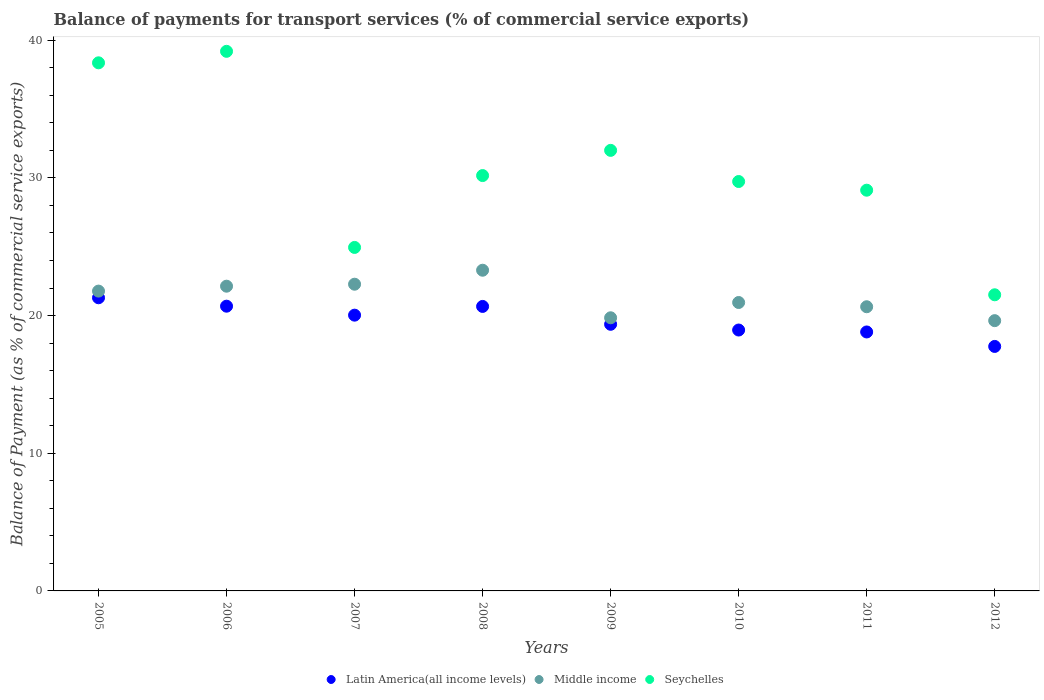Is the number of dotlines equal to the number of legend labels?
Give a very brief answer. Yes. What is the balance of payments for transport services in Seychelles in 2005?
Ensure brevity in your answer.  38.36. Across all years, what is the maximum balance of payments for transport services in Middle income?
Provide a short and direct response. 23.3. Across all years, what is the minimum balance of payments for transport services in Middle income?
Make the answer very short. 19.63. In which year was the balance of payments for transport services in Seychelles minimum?
Provide a short and direct response. 2012. What is the total balance of payments for transport services in Seychelles in the graph?
Ensure brevity in your answer.  245.04. What is the difference between the balance of payments for transport services in Seychelles in 2006 and that in 2010?
Give a very brief answer. 9.46. What is the difference between the balance of payments for transport services in Latin America(all income levels) in 2012 and the balance of payments for transport services in Middle income in 2007?
Provide a succinct answer. -4.52. What is the average balance of payments for transport services in Middle income per year?
Your response must be concise. 21.32. In the year 2011, what is the difference between the balance of payments for transport services in Middle income and balance of payments for transport services in Seychelles?
Your answer should be compact. -8.47. In how many years, is the balance of payments for transport services in Middle income greater than 36 %?
Offer a terse response. 0. What is the ratio of the balance of payments for transport services in Latin America(all income levels) in 2005 to that in 2011?
Your response must be concise. 1.13. What is the difference between the highest and the second highest balance of payments for transport services in Seychelles?
Your answer should be very brief. 0.83. What is the difference between the highest and the lowest balance of payments for transport services in Seychelles?
Offer a very short reply. 17.68. In how many years, is the balance of payments for transport services in Seychelles greater than the average balance of payments for transport services in Seychelles taken over all years?
Offer a terse response. 3. Does the balance of payments for transport services in Latin America(all income levels) monotonically increase over the years?
Offer a terse response. No. Is the balance of payments for transport services in Latin America(all income levels) strictly less than the balance of payments for transport services in Middle income over the years?
Your answer should be compact. Yes. How many dotlines are there?
Ensure brevity in your answer.  3. Are the values on the major ticks of Y-axis written in scientific E-notation?
Your answer should be very brief. No. Does the graph contain grids?
Provide a succinct answer. No. How are the legend labels stacked?
Give a very brief answer. Horizontal. What is the title of the graph?
Make the answer very short. Balance of payments for transport services (% of commercial service exports). What is the label or title of the X-axis?
Offer a terse response. Years. What is the label or title of the Y-axis?
Make the answer very short. Balance of Payment (as % of commercial service exports). What is the Balance of Payment (as % of commercial service exports) in Latin America(all income levels) in 2005?
Ensure brevity in your answer.  21.29. What is the Balance of Payment (as % of commercial service exports) of Middle income in 2005?
Your answer should be very brief. 21.78. What is the Balance of Payment (as % of commercial service exports) in Seychelles in 2005?
Offer a terse response. 38.36. What is the Balance of Payment (as % of commercial service exports) in Latin America(all income levels) in 2006?
Your answer should be compact. 20.68. What is the Balance of Payment (as % of commercial service exports) in Middle income in 2006?
Make the answer very short. 22.14. What is the Balance of Payment (as % of commercial service exports) of Seychelles in 2006?
Give a very brief answer. 39.2. What is the Balance of Payment (as % of commercial service exports) in Latin America(all income levels) in 2007?
Provide a short and direct response. 20.03. What is the Balance of Payment (as % of commercial service exports) of Middle income in 2007?
Your answer should be very brief. 22.28. What is the Balance of Payment (as % of commercial service exports) of Seychelles in 2007?
Provide a short and direct response. 24.95. What is the Balance of Payment (as % of commercial service exports) in Latin America(all income levels) in 2008?
Your answer should be compact. 20.67. What is the Balance of Payment (as % of commercial service exports) of Middle income in 2008?
Offer a terse response. 23.3. What is the Balance of Payment (as % of commercial service exports) in Seychelles in 2008?
Offer a very short reply. 30.17. What is the Balance of Payment (as % of commercial service exports) in Latin America(all income levels) in 2009?
Provide a short and direct response. 19.37. What is the Balance of Payment (as % of commercial service exports) in Middle income in 2009?
Your response must be concise. 19.84. What is the Balance of Payment (as % of commercial service exports) in Seychelles in 2009?
Offer a terse response. 32. What is the Balance of Payment (as % of commercial service exports) in Latin America(all income levels) in 2010?
Provide a succinct answer. 18.95. What is the Balance of Payment (as % of commercial service exports) of Middle income in 2010?
Your answer should be compact. 20.95. What is the Balance of Payment (as % of commercial service exports) of Seychelles in 2010?
Provide a succinct answer. 29.74. What is the Balance of Payment (as % of commercial service exports) in Latin America(all income levels) in 2011?
Keep it short and to the point. 18.81. What is the Balance of Payment (as % of commercial service exports) of Middle income in 2011?
Offer a terse response. 20.64. What is the Balance of Payment (as % of commercial service exports) of Seychelles in 2011?
Ensure brevity in your answer.  29.11. What is the Balance of Payment (as % of commercial service exports) of Latin America(all income levels) in 2012?
Make the answer very short. 17.76. What is the Balance of Payment (as % of commercial service exports) of Middle income in 2012?
Provide a short and direct response. 19.63. What is the Balance of Payment (as % of commercial service exports) of Seychelles in 2012?
Offer a terse response. 21.51. Across all years, what is the maximum Balance of Payment (as % of commercial service exports) of Latin America(all income levels)?
Provide a succinct answer. 21.29. Across all years, what is the maximum Balance of Payment (as % of commercial service exports) of Middle income?
Provide a short and direct response. 23.3. Across all years, what is the maximum Balance of Payment (as % of commercial service exports) of Seychelles?
Your answer should be compact. 39.2. Across all years, what is the minimum Balance of Payment (as % of commercial service exports) of Latin America(all income levels)?
Give a very brief answer. 17.76. Across all years, what is the minimum Balance of Payment (as % of commercial service exports) in Middle income?
Offer a terse response. 19.63. Across all years, what is the minimum Balance of Payment (as % of commercial service exports) in Seychelles?
Provide a short and direct response. 21.51. What is the total Balance of Payment (as % of commercial service exports) in Latin America(all income levels) in the graph?
Provide a succinct answer. 157.57. What is the total Balance of Payment (as % of commercial service exports) in Middle income in the graph?
Your response must be concise. 170.56. What is the total Balance of Payment (as % of commercial service exports) of Seychelles in the graph?
Your response must be concise. 245.04. What is the difference between the Balance of Payment (as % of commercial service exports) in Latin America(all income levels) in 2005 and that in 2006?
Offer a terse response. 0.61. What is the difference between the Balance of Payment (as % of commercial service exports) of Middle income in 2005 and that in 2006?
Provide a short and direct response. -0.36. What is the difference between the Balance of Payment (as % of commercial service exports) in Seychelles in 2005 and that in 2006?
Offer a terse response. -0.83. What is the difference between the Balance of Payment (as % of commercial service exports) of Latin America(all income levels) in 2005 and that in 2007?
Provide a succinct answer. 1.26. What is the difference between the Balance of Payment (as % of commercial service exports) in Middle income in 2005 and that in 2007?
Offer a very short reply. -0.5. What is the difference between the Balance of Payment (as % of commercial service exports) in Seychelles in 2005 and that in 2007?
Ensure brevity in your answer.  13.41. What is the difference between the Balance of Payment (as % of commercial service exports) of Latin America(all income levels) in 2005 and that in 2008?
Your answer should be compact. 0.63. What is the difference between the Balance of Payment (as % of commercial service exports) of Middle income in 2005 and that in 2008?
Offer a very short reply. -1.52. What is the difference between the Balance of Payment (as % of commercial service exports) of Seychelles in 2005 and that in 2008?
Keep it short and to the point. 8.19. What is the difference between the Balance of Payment (as % of commercial service exports) in Latin America(all income levels) in 2005 and that in 2009?
Provide a short and direct response. 1.93. What is the difference between the Balance of Payment (as % of commercial service exports) in Middle income in 2005 and that in 2009?
Your answer should be compact. 1.94. What is the difference between the Balance of Payment (as % of commercial service exports) of Seychelles in 2005 and that in 2009?
Keep it short and to the point. 6.36. What is the difference between the Balance of Payment (as % of commercial service exports) of Latin America(all income levels) in 2005 and that in 2010?
Your response must be concise. 2.34. What is the difference between the Balance of Payment (as % of commercial service exports) in Middle income in 2005 and that in 2010?
Your response must be concise. 0.83. What is the difference between the Balance of Payment (as % of commercial service exports) of Seychelles in 2005 and that in 2010?
Your response must be concise. 8.62. What is the difference between the Balance of Payment (as % of commercial service exports) of Latin America(all income levels) in 2005 and that in 2011?
Make the answer very short. 2.48. What is the difference between the Balance of Payment (as % of commercial service exports) in Middle income in 2005 and that in 2011?
Your response must be concise. 1.14. What is the difference between the Balance of Payment (as % of commercial service exports) of Seychelles in 2005 and that in 2011?
Make the answer very short. 9.25. What is the difference between the Balance of Payment (as % of commercial service exports) in Latin America(all income levels) in 2005 and that in 2012?
Ensure brevity in your answer.  3.54. What is the difference between the Balance of Payment (as % of commercial service exports) of Middle income in 2005 and that in 2012?
Your answer should be compact. 2.15. What is the difference between the Balance of Payment (as % of commercial service exports) in Seychelles in 2005 and that in 2012?
Make the answer very short. 16.85. What is the difference between the Balance of Payment (as % of commercial service exports) in Latin America(all income levels) in 2006 and that in 2007?
Offer a very short reply. 0.65. What is the difference between the Balance of Payment (as % of commercial service exports) of Middle income in 2006 and that in 2007?
Offer a terse response. -0.14. What is the difference between the Balance of Payment (as % of commercial service exports) in Seychelles in 2006 and that in 2007?
Keep it short and to the point. 14.25. What is the difference between the Balance of Payment (as % of commercial service exports) in Latin America(all income levels) in 2006 and that in 2008?
Make the answer very short. 0.02. What is the difference between the Balance of Payment (as % of commercial service exports) of Middle income in 2006 and that in 2008?
Your response must be concise. -1.16. What is the difference between the Balance of Payment (as % of commercial service exports) in Seychelles in 2006 and that in 2008?
Provide a short and direct response. 9.02. What is the difference between the Balance of Payment (as % of commercial service exports) of Latin America(all income levels) in 2006 and that in 2009?
Ensure brevity in your answer.  1.32. What is the difference between the Balance of Payment (as % of commercial service exports) of Middle income in 2006 and that in 2009?
Your answer should be compact. 2.29. What is the difference between the Balance of Payment (as % of commercial service exports) of Seychelles in 2006 and that in 2009?
Ensure brevity in your answer.  7.19. What is the difference between the Balance of Payment (as % of commercial service exports) in Latin America(all income levels) in 2006 and that in 2010?
Your answer should be very brief. 1.73. What is the difference between the Balance of Payment (as % of commercial service exports) of Middle income in 2006 and that in 2010?
Give a very brief answer. 1.19. What is the difference between the Balance of Payment (as % of commercial service exports) of Seychelles in 2006 and that in 2010?
Your answer should be very brief. 9.46. What is the difference between the Balance of Payment (as % of commercial service exports) of Latin America(all income levels) in 2006 and that in 2011?
Offer a terse response. 1.87. What is the difference between the Balance of Payment (as % of commercial service exports) of Middle income in 2006 and that in 2011?
Ensure brevity in your answer.  1.49. What is the difference between the Balance of Payment (as % of commercial service exports) of Seychelles in 2006 and that in 2011?
Provide a succinct answer. 10.09. What is the difference between the Balance of Payment (as % of commercial service exports) in Latin America(all income levels) in 2006 and that in 2012?
Your answer should be very brief. 2.92. What is the difference between the Balance of Payment (as % of commercial service exports) in Middle income in 2006 and that in 2012?
Offer a very short reply. 2.5. What is the difference between the Balance of Payment (as % of commercial service exports) of Seychelles in 2006 and that in 2012?
Make the answer very short. 17.68. What is the difference between the Balance of Payment (as % of commercial service exports) in Latin America(all income levels) in 2007 and that in 2008?
Keep it short and to the point. -0.63. What is the difference between the Balance of Payment (as % of commercial service exports) in Middle income in 2007 and that in 2008?
Give a very brief answer. -1.02. What is the difference between the Balance of Payment (as % of commercial service exports) in Seychelles in 2007 and that in 2008?
Provide a succinct answer. -5.22. What is the difference between the Balance of Payment (as % of commercial service exports) in Latin America(all income levels) in 2007 and that in 2009?
Provide a succinct answer. 0.66. What is the difference between the Balance of Payment (as % of commercial service exports) of Middle income in 2007 and that in 2009?
Your response must be concise. 2.44. What is the difference between the Balance of Payment (as % of commercial service exports) in Seychelles in 2007 and that in 2009?
Make the answer very short. -7.05. What is the difference between the Balance of Payment (as % of commercial service exports) of Latin America(all income levels) in 2007 and that in 2010?
Ensure brevity in your answer.  1.08. What is the difference between the Balance of Payment (as % of commercial service exports) of Middle income in 2007 and that in 2010?
Offer a terse response. 1.33. What is the difference between the Balance of Payment (as % of commercial service exports) of Seychelles in 2007 and that in 2010?
Offer a very short reply. -4.79. What is the difference between the Balance of Payment (as % of commercial service exports) in Latin America(all income levels) in 2007 and that in 2011?
Make the answer very short. 1.22. What is the difference between the Balance of Payment (as % of commercial service exports) in Middle income in 2007 and that in 2011?
Offer a very short reply. 1.64. What is the difference between the Balance of Payment (as % of commercial service exports) of Seychelles in 2007 and that in 2011?
Provide a succinct answer. -4.16. What is the difference between the Balance of Payment (as % of commercial service exports) of Latin America(all income levels) in 2007 and that in 2012?
Offer a very short reply. 2.27. What is the difference between the Balance of Payment (as % of commercial service exports) in Middle income in 2007 and that in 2012?
Provide a short and direct response. 2.65. What is the difference between the Balance of Payment (as % of commercial service exports) of Seychelles in 2007 and that in 2012?
Keep it short and to the point. 3.44. What is the difference between the Balance of Payment (as % of commercial service exports) in Latin America(all income levels) in 2008 and that in 2009?
Provide a short and direct response. 1.3. What is the difference between the Balance of Payment (as % of commercial service exports) of Middle income in 2008 and that in 2009?
Provide a short and direct response. 3.45. What is the difference between the Balance of Payment (as % of commercial service exports) in Seychelles in 2008 and that in 2009?
Keep it short and to the point. -1.83. What is the difference between the Balance of Payment (as % of commercial service exports) of Latin America(all income levels) in 2008 and that in 2010?
Ensure brevity in your answer.  1.71. What is the difference between the Balance of Payment (as % of commercial service exports) in Middle income in 2008 and that in 2010?
Keep it short and to the point. 2.34. What is the difference between the Balance of Payment (as % of commercial service exports) in Seychelles in 2008 and that in 2010?
Give a very brief answer. 0.43. What is the difference between the Balance of Payment (as % of commercial service exports) in Latin America(all income levels) in 2008 and that in 2011?
Give a very brief answer. 1.85. What is the difference between the Balance of Payment (as % of commercial service exports) in Middle income in 2008 and that in 2011?
Keep it short and to the point. 2.65. What is the difference between the Balance of Payment (as % of commercial service exports) of Seychelles in 2008 and that in 2011?
Provide a succinct answer. 1.06. What is the difference between the Balance of Payment (as % of commercial service exports) in Latin America(all income levels) in 2008 and that in 2012?
Provide a succinct answer. 2.91. What is the difference between the Balance of Payment (as % of commercial service exports) in Middle income in 2008 and that in 2012?
Make the answer very short. 3.66. What is the difference between the Balance of Payment (as % of commercial service exports) in Seychelles in 2008 and that in 2012?
Ensure brevity in your answer.  8.66. What is the difference between the Balance of Payment (as % of commercial service exports) of Latin America(all income levels) in 2009 and that in 2010?
Your response must be concise. 0.42. What is the difference between the Balance of Payment (as % of commercial service exports) in Middle income in 2009 and that in 2010?
Ensure brevity in your answer.  -1.11. What is the difference between the Balance of Payment (as % of commercial service exports) of Seychelles in 2009 and that in 2010?
Provide a succinct answer. 2.26. What is the difference between the Balance of Payment (as % of commercial service exports) in Latin America(all income levels) in 2009 and that in 2011?
Keep it short and to the point. 0.56. What is the difference between the Balance of Payment (as % of commercial service exports) in Middle income in 2009 and that in 2011?
Your answer should be very brief. -0.8. What is the difference between the Balance of Payment (as % of commercial service exports) in Seychelles in 2009 and that in 2011?
Keep it short and to the point. 2.89. What is the difference between the Balance of Payment (as % of commercial service exports) in Latin America(all income levels) in 2009 and that in 2012?
Make the answer very short. 1.61. What is the difference between the Balance of Payment (as % of commercial service exports) of Middle income in 2009 and that in 2012?
Keep it short and to the point. 0.21. What is the difference between the Balance of Payment (as % of commercial service exports) in Seychelles in 2009 and that in 2012?
Ensure brevity in your answer.  10.49. What is the difference between the Balance of Payment (as % of commercial service exports) in Latin America(all income levels) in 2010 and that in 2011?
Provide a short and direct response. 0.14. What is the difference between the Balance of Payment (as % of commercial service exports) in Middle income in 2010 and that in 2011?
Your answer should be compact. 0.31. What is the difference between the Balance of Payment (as % of commercial service exports) of Seychelles in 2010 and that in 2011?
Keep it short and to the point. 0.63. What is the difference between the Balance of Payment (as % of commercial service exports) of Latin America(all income levels) in 2010 and that in 2012?
Offer a very short reply. 1.19. What is the difference between the Balance of Payment (as % of commercial service exports) of Middle income in 2010 and that in 2012?
Provide a short and direct response. 1.32. What is the difference between the Balance of Payment (as % of commercial service exports) of Seychelles in 2010 and that in 2012?
Your response must be concise. 8.23. What is the difference between the Balance of Payment (as % of commercial service exports) in Latin America(all income levels) in 2011 and that in 2012?
Offer a very short reply. 1.05. What is the difference between the Balance of Payment (as % of commercial service exports) of Middle income in 2011 and that in 2012?
Your response must be concise. 1.01. What is the difference between the Balance of Payment (as % of commercial service exports) in Seychelles in 2011 and that in 2012?
Your answer should be very brief. 7.6. What is the difference between the Balance of Payment (as % of commercial service exports) in Latin America(all income levels) in 2005 and the Balance of Payment (as % of commercial service exports) in Middle income in 2006?
Provide a succinct answer. -0.84. What is the difference between the Balance of Payment (as % of commercial service exports) of Latin America(all income levels) in 2005 and the Balance of Payment (as % of commercial service exports) of Seychelles in 2006?
Ensure brevity in your answer.  -17.9. What is the difference between the Balance of Payment (as % of commercial service exports) in Middle income in 2005 and the Balance of Payment (as % of commercial service exports) in Seychelles in 2006?
Your answer should be very brief. -17.42. What is the difference between the Balance of Payment (as % of commercial service exports) in Latin America(all income levels) in 2005 and the Balance of Payment (as % of commercial service exports) in Middle income in 2007?
Offer a terse response. -0.98. What is the difference between the Balance of Payment (as % of commercial service exports) in Latin America(all income levels) in 2005 and the Balance of Payment (as % of commercial service exports) in Seychelles in 2007?
Provide a succinct answer. -3.66. What is the difference between the Balance of Payment (as % of commercial service exports) in Middle income in 2005 and the Balance of Payment (as % of commercial service exports) in Seychelles in 2007?
Offer a very short reply. -3.17. What is the difference between the Balance of Payment (as % of commercial service exports) of Latin America(all income levels) in 2005 and the Balance of Payment (as % of commercial service exports) of Middle income in 2008?
Make the answer very short. -2. What is the difference between the Balance of Payment (as % of commercial service exports) in Latin America(all income levels) in 2005 and the Balance of Payment (as % of commercial service exports) in Seychelles in 2008?
Offer a terse response. -8.88. What is the difference between the Balance of Payment (as % of commercial service exports) of Middle income in 2005 and the Balance of Payment (as % of commercial service exports) of Seychelles in 2008?
Make the answer very short. -8.39. What is the difference between the Balance of Payment (as % of commercial service exports) in Latin America(all income levels) in 2005 and the Balance of Payment (as % of commercial service exports) in Middle income in 2009?
Your answer should be compact. 1.45. What is the difference between the Balance of Payment (as % of commercial service exports) in Latin America(all income levels) in 2005 and the Balance of Payment (as % of commercial service exports) in Seychelles in 2009?
Your response must be concise. -10.71. What is the difference between the Balance of Payment (as % of commercial service exports) in Middle income in 2005 and the Balance of Payment (as % of commercial service exports) in Seychelles in 2009?
Your answer should be very brief. -10.22. What is the difference between the Balance of Payment (as % of commercial service exports) in Latin America(all income levels) in 2005 and the Balance of Payment (as % of commercial service exports) in Middle income in 2010?
Keep it short and to the point. 0.34. What is the difference between the Balance of Payment (as % of commercial service exports) of Latin America(all income levels) in 2005 and the Balance of Payment (as % of commercial service exports) of Seychelles in 2010?
Keep it short and to the point. -8.44. What is the difference between the Balance of Payment (as % of commercial service exports) of Middle income in 2005 and the Balance of Payment (as % of commercial service exports) of Seychelles in 2010?
Your answer should be very brief. -7.96. What is the difference between the Balance of Payment (as % of commercial service exports) of Latin America(all income levels) in 2005 and the Balance of Payment (as % of commercial service exports) of Middle income in 2011?
Give a very brief answer. 0.65. What is the difference between the Balance of Payment (as % of commercial service exports) of Latin America(all income levels) in 2005 and the Balance of Payment (as % of commercial service exports) of Seychelles in 2011?
Provide a short and direct response. -7.81. What is the difference between the Balance of Payment (as % of commercial service exports) of Middle income in 2005 and the Balance of Payment (as % of commercial service exports) of Seychelles in 2011?
Your answer should be very brief. -7.33. What is the difference between the Balance of Payment (as % of commercial service exports) of Latin America(all income levels) in 2005 and the Balance of Payment (as % of commercial service exports) of Middle income in 2012?
Your answer should be compact. 1.66. What is the difference between the Balance of Payment (as % of commercial service exports) of Latin America(all income levels) in 2005 and the Balance of Payment (as % of commercial service exports) of Seychelles in 2012?
Your answer should be very brief. -0.22. What is the difference between the Balance of Payment (as % of commercial service exports) of Middle income in 2005 and the Balance of Payment (as % of commercial service exports) of Seychelles in 2012?
Make the answer very short. 0.27. What is the difference between the Balance of Payment (as % of commercial service exports) in Latin America(all income levels) in 2006 and the Balance of Payment (as % of commercial service exports) in Middle income in 2007?
Keep it short and to the point. -1.6. What is the difference between the Balance of Payment (as % of commercial service exports) in Latin America(all income levels) in 2006 and the Balance of Payment (as % of commercial service exports) in Seychelles in 2007?
Your answer should be compact. -4.27. What is the difference between the Balance of Payment (as % of commercial service exports) in Middle income in 2006 and the Balance of Payment (as % of commercial service exports) in Seychelles in 2007?
Give a very brief answer. -2.82. What is the difference between the Balance of Payment (as % of commercial service exports) in Latin America(all income levels) in 2006 and the Balance of Payment (as % of commercial service exports) in Middle income in 2008?
Ensure brevity in your answer.  -2.61. What is the difference between the Balance of Payment (as % of commercial service exports) in Latin America(all income levels) in 2006 and the Balance of Payment (as % of commercial service exports) in Seychelles in 2008?
Ensure brevity in your answer.  -9.49. What is the difference between the Balance of Payment (as % of commercial service exports) in Middle income in 2006 and the Balance of Payment (as % of commercial service exports) in Seychelles in 2008?
Your response must be concise. -8.04. What is the difference between the Balance of Payment (as % of commercial service exports) in Latin America(all income levels) in 2006 and the Balance of Payment (as % of commercial service exports) in Middle income in 2009?
Your answer should be compact. 0.84. What is the difference between the Balance of Payment (as % of commercial service exports) of Latin America(all income levels) in 2006 and the Balance of Payment (as % of commercial service exports) of Seychelles in 2009?
Ensure brevity in your answer.  -11.32. What is the difference between the Balance of Payment (as % of commercial service exports) in Middle income in 2006 and the Balance of Payment (as % of commercial service exports) in Seychelles in 2009?
Offer a very short reply. -9.87. What is the difference between the Balance of Payment (as % of commercial service exports) in Latin America(all income levels) in 2006 and the Balance of Payment (as % of commercial service exports) in Middle income in 2010?
Provide a succinct answer. -0.27. What is the difference between the Balance of Payment (as % of commercial service exports) in Latin America(all income levels) in 2006 and the Balance of Payment (as % of commercial service exports) in Seychelles in 2010?
Provide a succinct answer. -9.06. What is the difference between the Balance of Payment (as % of commercial service exports) in Middle income in 2006 and the Balance of Payment (as % of commercial service exports) in Seychelles in 2010?
Offer a terse response. -7.6. What is the difference between the Balance of Payment (as % of commercial service exports) in Latin America(all income levels) in 2006 and the Balance of Payment (as % of commercial service exports) in Middle income in 2011?
Offer a very short reply. 0.04. What is the difference between the Balance of Payment (as % of commercial service exports) of Latin America(all income levels) in 2006 and the Balance of Payment (as % of commercial service exports) of Seychelles in 2011?
Your answer should be compact. -8.43. What is the difference between the Balance of Payment (as % of commercial service exports) of Middle income in 2006 and the Balance of Payment (as % of commercial service exports) of Seychelles in 2011?
Give a very brief answer. -6.97. What is the difference between the Balance of Payment (as % of commercial service exports) in Latin America(all income levels) in 2006 and the Balance of Payment (as % of commercial service exports) in Middle income in 2012?
Make the answer very short. 1.05. What is the difference between the Balance of Payment (as % of commercial service exports) in Latin America(all income levels) in 2006 and the Balance of Payment (as % of commercial service exports) in Seychelles in 2012?
Offer a very short reply. -0.83. What is the difference between the Balance of Payment (as % of commercial service exports) of Middle income in 2006 and the Balance of Payment (as % of commercial service exports) of Seychelles in 2012?
Your response must be concise. 0.62. What is the difference between the Balance of Payment (as % of commercial service exports) in Latin America(all income levels) in 2007 and the Balance of Payment (as % of commercial service exports) in Middle income in 2008?
Offer a very short reply. -3.26. What is the difference between the Balance of Payment (as % of commercial service exports) of Latin America(all income levels) in 2007 and the Balance of Payment (as % of commercial service exports) of Seychelles in 2008?
Provide a short and direct response. -10.14. What is the difference between the Balance of Payment (as % of commercial service exports) in Middle income in 2007 and the Balance of Payment (as % of commercial service exports) in Seychelles in 2008?
Ensure brevity in your answer.  -7.89. What is the difference between the Balance of Payment (as % of commercial service exports) of Latin America(all income levels) in 2007 and the Balance of Payment (as % of commercial service exports) of Middle income in 2009?
Ensure brevity in your answer.  0.19. What is the difference between the Balance of Payment (as % of commercial service exports) of Latin America(all income levels) in 2007 and the Balance of Payment (as % of commercial service exports) of Seychelles in 2009?
Give a very brief answer. -11.97. What is the difference between the Balance of Payment (as % of commercial service exports) in Middle income in 2007 and the Balance of Payment (as % of commercial service exports) in Seychelles in 2009?
Offer a terse response. -9.72. What is the difference between the Balance of Payment (as % of commercial service exports) of Latin America(all income levels) in 2007 and the Balance of Payment (as % of commercial service exports) of Middle income in 2010?
Offer a terse response. -0.92. What is the difference between the Balance of Payment (as % of commercial service exports) of Latin America(all income levels) in 2007 and the Balance of Payment (as % of commercial service exports) of Seychelles in 2010?
Make the answer very short. -9.71. What is the difference between the Balance of Payment (as % of commercial service exports) in Middle income in 2007 and the Balance of Payment (as % of commercial service exports) in Seychelles in 2010?
Keep it short and to the point. -7.46. What is the difference between the Balance of Payment (as % of commercial service exports) of Latin America(all income levels) in 2007 and the Balance of Payment (as % of commercial service exports) of Middle income in 2011?
Your answer should be very brief. -0.61. What is the difference between the Balance of Payment (as % of commercial service exports) in Latin America(all income levels) in 2007 and the Balance of Payment (as % of commercial service exports) in Seychelles in 2011?
Your answer should be very brief. -9.08. What is the difference between the Balance of Payment (as % of commercial service exports) in Middle income in 2007 and the Balance of Payment (as % of commercial service exports) in Seychelles in 2011?
Ensure brevity in your answer.  -6.83. What is the difference between the Balance of Payment (as % of commercial service exports) in Latin America(all income levels) in 2007 and the Balance of Payment (as % of commercial service exports) in Middle income in 2012?
Give a very brief answer. 0.4. What is the difference between the Balance of Payment (as % of commercial service exports) in Latin America(all income levels) in 2007 and the Balance of Payment (as % of commercial service exports) in Seychelles in 2012?
Make the answer very short. -1.48. What is the difference between the Balance of Payment (as % of commercial service exports) of Middle income in 2007 and the Balance of Payment (as % of commercial service exports) of Seychelles in 2012?
Offer a very short reply. 0.77. What is the difference between the Balance of Payment (as % of commercial service exports) in Latin America(all income levels) in 2008 and the Balance of Payment (as % of commercial service exports) in Middle income in 2009?
Offer a terse response. 0.82. What is the difference between the Balance of Payment (as % of commercial service exports) in Latin America(all income levels) in 2008 and the Balance of Payment (as % of commercial service exports) in Seychelles in 2009?
Ensure brevity in your answer.  -11.34. What is the difference between the Balance of Payment (as % of commercial service exports) of Middle income in 2008 and the Balance of Payment (as % of commercial service exports) of Seychelles in 2009?
Ensure brevity in your answer.  -8.71. What is the difference between the Balance of Payment (as % of commercial service exports) of Latin America(all income levels) in 2008 and the Balance of Payment (as % of commercial service exports) of Middle income in 2010?
Provide a succinct answer. -0.28. What is the difference between the Balance of Payment (as % of commercial service exports) in Latin America(all income levels) in 2008 and the Balance of Payment (as % of commercial service exports) in Seychelles in 2010?
Keep it short and to the point. -9.07. What is the difference between the Balance of Payment (as % of commercial service exports) of Middle income in 2008 and the Balance of Payment (as % of commercial service exports) of Seychelles in 2010?
Ensure brevity in your answer.  -6.44. What is the difference between the Balance of Payment (as % of commercial service exports) in Latin America(all income levels) in 2008 and the Balance of Payment (as % of commercial service exports) in Middle income in 2011?
Provide a succinct answer. 0.02. What is the difference between the Balance of Payment (as % of commercial service exports) in Latin America(all income levels) in 2008 and the Balance of Payment (as % of commercial service exports) in Seychelles in 2011?
Provide a succinct answer. -8.44. What is the difference between the Balance of Payment (as % of commercial service exports) in Middle income in 2008 and the Balance of Payment (as % of commercial service exports) in Seychelles in 2011?
Provide a short and direct response. -5.81. What is the difference between the Balance of Payment (as % of commercial service exports) in Latin America(all income levels) in 2008 and the Balance of Payment (as % of commercial service exports) in Middle income in 2012?
Make the answer very short. 1.03. What is the difference between the Balance of Payment (as % of commercial service exports) in Latin America(all income levels) in 2008 and the Balance of Payment (as % of commercial service exports) in Seychelles in 2012?
Keep it short and to the point. -0.85. What is the difference between the Balance of Payment (as % of commercial service exports) of Middle income in 2008 and the Balance of Payment (as % of commercial service exports) of Seychelles in 2012?
Provide a short and direct response. 1.78. What is the difference between the Balance of Payment (as % of commercial service exports) in Latin America(all income levels) in 2009 and the Balance of Payment (as % of commercial service exports) in Middle income in 2010?
Make the answer very short. -1.58. What is the difference between the Balance of Payment (as % of commercial service exports) of Latin America(all income levels) in 2009 and the Balance of Payment (as % of commercial service exports) of Seychelles in 2010?
Provide a short and direct response. -10.37. What is the difference between the Balance of Payment (as % of commercial service exports) in Middle income in 2009 and the Balance of Payment (as % of commercial service exports) in Seychelles in 2010?
Keep it short and to the point. -9.9. What is the difference between the Balance of Payment (as % of commercial service exports) of Latin America(all income levels) in 2009 and the Balance of Payment (as % of commercial service exports) of Middle income in 2011?
Offer a terse response. -1.27. What is the difference between the Balance of Payment (as % of commercial service exports) in Latin America(all income levels) in 2009 and the Balance of Payment (as % of commercial service exports) in Seychelles in 2011?
Give a very brief answer. -9.74. What is the difference between the Balance of Payment (as % of commercial service exports) of Middle income in 2009 and the Balance of Payment (as % of commercial service exports) of Seychelles in 2011?
Make the answer very short. -9.27. What is the difference between the Balance of Payment (as % of commercial service exports) in Latin America(all income levels) in 2009 and the Balance of Payment (as % of commercial service exports) in Middle income in 2012?
Provide a short and direct response. -0.26. What is the difference between the Balance of Payment (as % of commercial service exports) in Latin America(all income levels) in 2009 and the Balance of Payment (as % of commercial service exports) in Seychelles in 2012?
Offer a terse response. -2.14. What is the difference between the Balance of Payment (as % of commercial service exports) of Middle income in 2009 and the Balance of Payment (as % of commercial service exports) of Seychelles in 2012?
Your answer should be very brief. -1.67. What is the difference between the Balance of Payment (as % of commercial service exports) of Latin America(all income levels) in 2010 and the Balance of Payment (as % of commercial service exports) of Middle income in 2011?
Your answer should be compact. -1.69. What is the difference between the Balance of Payment (as % of commercial service exports) in Latin America(all income levels) in 2010 and the Balance of Payment (as % of commercial service exports) in Seychelles in 2011?
Give a very brief answer. -10.16. What is the difference between the Balance of Payment (as % of commercial service exports) in Middle income in 2010 and the Balance of Payment (as % of commercial service exports) in Seychelles in 2011?
Your answer should be compact. -8.16. What is the difference between the Balance of Payment (as % of commercial service exports) of Latin America(all income levels) in 2010 and the Balance of Payment (as % of commercial service exports) of Middle income in 2012?
Your answer should be compact. -0.68. What is the difference between the Balance of Payment (as % of commercial service exports) of Latin America(all income levels) in 2010 and the Balance of Payment (as % of commercial service exports) of Seychelles in 2012?
Your answer should be very brief. -2.56. What is the difference between the Balance of Payment (as % of commercial service exports) in Middle income in 2010 and the Balance of Payment (as % of commercial service exports) in Seychelles in 2012?
Your answer should be very brief. -0.56. What is the difference between the Balance of Payment (as % of commercial service exports) of Latin America(all income levels) in 2011 and the Balance of Payment (as % of commercial service exports) of Middle income in 2012?
Provide a short and direct response. -0.82. What is the difference between the Balance of Payment (as % of commercial service exports) of Latin America(all income levels) in 2011 and the Balance of Payment (as % of commercial service exports) of Seychelles in 2012?
Your answer should be compact. -2.7. What is the difference between the Balance of Payment (as % of commercial service exports) in Middle income in 2011 and the Balance of Payment (as % of commercial service exports) in Seychelles in 2012?
Your answer should be very brief. -0.87. What is the average Balance of Payment (as % of commercial service exports) in Latin America(all income levels) per year?
Provide a short and direct response. 19.7. What is the average Balance of Payment (as % of commercial service exports) of Middle income per year?
Your answer should be compact. 21.32. What is the average Balance of Payment (as % of commercial service exports) of Seychelles per year?
Offer a very short reply. 30.63. In the year 2005, what is the difference between the Balance of Payment (as % of commercial service exports) in Latin America(all income levels) and Balance of Payment (as % of commercial service exports) in Middle income?
Your answer should be very brief. -0.48. In the year 2005, what is the difference between the Balance of Payment (as % of commercial service exports) in Latin America(all income levels) and Balance of Payment (as % of commercial service exports) in Seychelles?
Provide a succinct answer. -17.07. In the year 2005, what is the difference between the Balance of Payment (as % of commercial service exports) of Middle income and Balance of Payment (as % of commercial service exports) of Seychelles?
Make the answer very short. -16.58. In the year 2006, what is the difference between the Balance of Payment (as % of commercial service exports) of Latin America(all income levels) and Balance of Payment (as % of commercial service exports) of Middle income?
Your answer should be very brief. -1.45. In the year 2006, what is the difference between the Balance of Payment (as % of commercial service exports) of Latin America(all income levels) and Balance of Payment (as % of commercial service exports) of Seychelles?
Provide a succinct answer. -18.51. In the year 2006, what is the difference between the Balance of Payment (as % of commercial service exports) in Middle income and Balance of Payment (as % of commercial service exports) in Seychelles?
Provide a short and direct response. -17.06. In the year 2007, what is the difference between the Balance of Payment (as % of commercial service exports) of Latin America(all income levels) and Balance of Payment (as % of commercial service exports) of Middle income?
Provide a short and direct response. -2.25. In the year 2007, what is the difference between the Balance of Payment (as % of commercial service exports) in Latin America(all income levels) and Balance of Payment (as % of commercial service exports) in Seychelles?
Provide a succinct answer. -4.92. In the year 2007, what is the difference between the Balance of Payment (as % of commercial service exports) of Middle income and Balance of Payment (as % of commercial service exports) of Seychelles?
Your answer should be very brief. -2.67. In the year 2008, what is the difference between the Balance of Payment (as % of commercial service exports) in Latin America(all income levels) and Balance of Payment (as % of commercial service exports) in Middle income?
Make the answer very short. -2.63. In the year 2008, what is the difference between the Balance of Payment (as % of commercial service exports) in Latin America(all income levels) and Balance of Payment (as % of commercial service exports) in Seychelles?
Offer a terse response. -9.51. In the year 2008, what is the difference between the Balance of Payment (as % of commercial service exports) in Middle income and Balance of Payment (as % of commercial service exports) in Seychelles?
Offer a terse response. -6.88. In the year 2009, what is the difference between the Balance of Payment (as % of commercial service exports) in Latin America(all income levels) and Balance of Payment (as % of commercial service exports) in Middle income?
Offer a very short reply. -0.47. In the year 2009, what is the difference between the Balance of Payment (as % of commercial service exports) in Latin America(all income levels) and Balance of Payment (as % of commercial service exports) in Seychelles?
Offer a terse response. -12.63. In the year 2009, what is the difference between the Balance of Payment (as % of commercial service exports) in Middle income and Balance of Payment (as % of commercial service exports) in Seychelles?
Offer a very short reply. -12.16. In the year 2010, what is the difference between the Balance of Payment (as % of commercial service exports) in Latin America(all income levels) and Balance of Payment (as % of commercial service exports) in Middle income?
Provide a short and direct response. -2. In the year 2010, what is the difference between the Balance of Payment (as % of commercial service exports) of Latin America(all income levels) and Balance of Payment (as % of commercial service exports) of Seychelles?
Offer a terse response. -10.79. In the year 2010, what is the difference between the Balance of Payment (as % of commercial service exports) of Middle income and Balance of Payment (as % of commercial service exports) of Seychelles?
Provide a short and direct response. -8.79. In the year 2011, what is the difference between the Balance of Payment (as % of commercial service exports) in Latin America(all income levels) and Balance of Payment (as % of commercial service exports) in Middle income?
Your answer should be very brief. -1.83. In the year 2011, what is the difference between the Balance of Payment (as % of commercial service exports) of Latin America(all income levels) and Balance of Payment (as % of commercial service exports) of Seychelles?
Offer a terse response. -10.3. In the year 2011, what is the difference between the Balance of Payment (as % of commercial service exports) in Middle income and Balance of Payment (as % of commercial service exports) in Seychelles?
Give a very brief answer. -8.47. In the year 2012, what is the difference between the Balance of Payment (as % of commercial service exports) of Latin America(all income levels) and Balance of Payment (as % of commercial service exports) of Middle income?
Offer a very short reply. -1.87. In the year 2012, what is the difference between the Balance of Payment (as % of commercial service exports) in Latin America(all income levels) and Balance of Payment (as % of commercial service exports) in Seychelles?
Provide a short and direct response. -3.75. In the year 2012, what is the difference between the Balance of Payment (as % of commercial service exports) of Middle income and Balance of Payment (as % of commercial service exports) of Seychelles?
Provide a short and direct response. -1.88. What is the ratio of the Balance of Payment (as % of commercial service exports) in Latin America(all income levels) in 2005 to that in 2006?
Offer a very short reply. 1.03. What is the ratio of the Balance of Payment (as % of commercial service exports) in Middle income in 2005 to that in 2006?
Keep it short and to the point. 0.98. What is the ratio of the Balance of Payment (as % of commercial service exports) in Seychelles in 2005 to that in 2006?
Provide a short and direct response. 0.98. What is the ratio of the Balance of Payment (as % of commercial service exports) of Latin America(all income levels) in 2005 to that in 2007?
Your answer should be compact. 1.06. What is the ratio of the Balance of Payment (as % of commercial service exports) in Middle income in 2005 to that in 2007?
Your answer should be compact. 0.98. What is the ratio of the Balance of Payment (as % of commercial service exports) of Seychelles in 2005 to that in 2007?
Your answer should be very brief. 1.54. What is the ratio of the Balance of Payment (as % of commercial service exports) of Latin America(all income levels) in 2005 to that in 2008?
Your response must be concise. 1.03. What is the ratio of the Balance of Payment (as % of commercial service exports) of Middle income in 2005 to that in 2008?
Your answer should be compact. 0.93. What is the ratio of the Balance of Payment (as % of commercial service exports) of Seychelles in 2005 to that in 2008?
Provide a short and direct response. 1.27. What is the ratio of the Balance of Payment (as % of commercial service exports) in Latin America(all income levels) in 2005 to that in 2009?
Offer a very short reply. 1.1. What is the ratio of the Balance of Payment (as % of commercial service exports) in Middle income in 2005 to that in 2009?
Ensure brevity in your answer.  1.1. What is the ratio of the Balance of Payment (as % of commercial service exports) in Seychelles in 2005 to that in 2009?
Ensure brevity in your answer.  1.2. What is the ratio of the Balance of Payment (as % of commercial service exports) in Latin America(all income levels) in 2005 to that in 2010?
Offer a terse response. 1.12. What is the ratio of the Balance of Payment (as % of commercial service exports) in Middle income in 2005 to that in 2010?
Make the answer very short. 1.04. What is the ratio of the Balance of Payment (as % of commercial service exports) of Seychelles in 2005 to that in 2010?
Your answer should be compact. 1.29. What is the ratio of the Balance of Payment (as % of commercial service exports) in Latin America(all income levels) in 2005 to that in 2011?
Your response must be concise. 1.13. What is the ratio of the Balance of Payment (as % of commercial service exports) in Middle income in 2005 to that in 2011?
Provide a succinct answer. 1.06. What is the ratio of the Balance of Payment (as % of commercial service exports) in Seychelles in 2005 to that in 2011?
Provide a succinct answer. 1.32. What is the ratio of the Balance of Payment (as % of commercial service exports) of Latin America(all income levels) in 2005 to that in 2012?
Your answer should be compact. 1.2. What is the ratio of the Balance of Payment (as % of commercial service exports) in Middle income in 2005 to that in 2012?
Provide a short and direct response. 1.11. What is the ratio of the Balance of Payment (as % of commercial service exports) in Seychelles in 2005 to that in 2012?
Ensure brevity in your answer.  1.78. What is the ratio of the Balance of Payment (as % of commercial service exports) in Latin America(all income levels) in 2006 to that in 2007?
Ensure brevity in your answer.  1.03. What is the ratio of the Balance of Payment (as % of commercial service exports) in Middle income in 2006 to that in 2007?
Offer a very short reply. 0.99. What is the ratio of the Balance of Payment (as % of commercial service exports) of Seychelles in 2006 to that in 2007?
Ensure brevity in your answer.  1.57. What is the ratio of the Balance of Payment (as % of commercial service exports) in Middle income in 2006 to that in 2008?
Your answer should be compact. 0.95. What is the ratio of the Balance of Payment (as % of commercial service exports) of Seychelles in 2006 to that in 2008?
Make the answer very short. 1.3. What is the ratio of the Balance of Payment (as % of commercial service exports) of Latin America(all income levels) in 2006 to that in 2009?
Keep it short and to the point. 1.07. What is the ratio of the Balance of Payment (as % of commercial service exports) in Middle income in 2006 to that in 2009?
Make the answer very short. 1.12. What is the ratio of the Balance of Payment (as % of commercial service exports) of Seychelles in 2006 to that in 2009?
Your response must be concise. 1.22. What is the ratio of the Balance of Payment (as % of commercial service exports) of Latin America(all income levels) in 2006 to that in 2010?
Your answer should be compact. 1.09. What is the ratio of the Balance of Payment (as % of commercial service exports) in Middle income in 2006 to that in 2010?
Provide a short and direct response. 1.06. What is the ratio of the Balance of Payment (as % of commercial service exports) of Seychelles in 2006 to that in 2010?
Ensure brevity in your answer.  1.32. What is the ratio of the Balance of Payment (as % of commercial service exports) of Latin America(all income levels) in 2006 to that in 2011?
Keep it short and to the point. 1.1. What is the ratio of the Balance of Payment (as % of commercial service exports) in Middle income in 2006 to that in 2011?
Your answer should be compact. 1.07. What is the ratio of the Balance of Payment (as % of commercial service exports) in Seychelles in 2006 to that in 2011?
Keep it short and to the point. 1.35. What is the ratio of the Balance of Payment (as % of commercial service exports) of Latin America(all income levels) in 2006 to that in 2012?
Offer a very short reply. 1.16. What is the ratio of the Balance of Payment (as % of commercial service exports) of Middle income in 2006 to that in 2012?
Your answer should be very brief. 1.13. What is the ratio of the Balance of Payment (as % of commercial service exports) in Seychelles in 2006 to that in 2012?
Offer a terse response. 1.82. What is the ratio of the Balance of Payment (as % of commercial service exports) of Latin America(all income levels) in 2007 to that in 2008?
Keep it short and to the point. 0.97. What is the ratio of the Balance of Payment (as % of commercial service exports) of Middle income in 2007 to that in 2008?
Your answer should be compact. 0.96. What is the ratio of the Balance of Payment (as % of commercial service exports) in Seychelles in 2007 to that in 2008?
Your answer should be very brief. 0.83. What is the ratio of the Balance of Payment (as % of commercial service exports) in Latin America(all income levels) in 2007 to that in 2009?
Offer a very short reply. 1.03. What is the ratio of the Balance of Payment (as % of commercial service exports) in Middle income in 2007 to that in 2009?
Provide a succinct answer. 1.12. What is the ratio of the Balance of Payment (as % of commercial service exports) in Seychelles in 2007 to that in 2009?
Provide a short and direct response. 0.78. What is the ratio of the Balance of Payment (as % of commercial service exports) in Latin America(all income levels) in 2007 to that in 2010?
Provide a short and direct response. 1.06. What is the ratio of the Balance of Payment (as % of commercial service exports) of Middle income in 2007 to that in 2010?
Keep it short and to the point. 1.06. What is the ratio of the Balance of Payment (as % of commercial service exports) of Seychelles in 2007 to that in 2010?
Make the answer very short. 0.84. What is the ratio of the Balance of Payment (as % of commercial service exports) of Latin America(all income levels) in 2007 to that in 2011?
Offer a very short reply. 1.06. What is the ratio of the Balance of Payment (as % of commercial service exports) in Middle income in 2007 to that in 2011?
Offer a very short reply. 1.08. What is the ratio of the Balance of Payment (as % of commercial service exports) of Seychelles in 2007 to that in 2011?
Give a very brief answer. 0.86. What is the ratio of the Balance of Payment (as % of commercial service exports) in Latin America(all income levels) in 2007 to that in 2012?
Offer a very short reply. 1.13. What is the ratio of the Balance of Payment (as % of commercial service exports) of Middle income in 2007 to that in 2012?
Your answer should be compact. 1.13. What is the ratio of the Balance of Payment (as % of commercial service exports) in Seychelles in 2007 to that in 2012?
Offer a very short reply. 1.16. What is the ratio of the Balance of Payment (as % of commercial service exports) in Latin America(all income levels) in 2008 to that in 2009?
Your answer should be compact. 1.07. What is the ratio of the Balance of Payment (as % of commercial service exports) of Middle income in 2008 to that in 2009?
Make the answer very short. 1.17. What is the ratio of the Balance of Payment (as % of commercial service exports) in Seychelles in 2008 to that in 2009?
Offer a terse response. 0.94. What is the ratio of the Balance of Payment (as % of commercial service exports) in Latin America(all income levels) in 2008 to that in 2010?
Your answer should be compact. 1.09. What is the ratio of the Balance of Payment (as % of commercial service exports) in Middle income in 2008 to that in 2010?
Offer a very short reply. 1.11. What is the ratio of the Balance of Payment (as % of commercial service exports) of Seychelles in 2008 to that in 2010?
Keep it short and to the point. 1.01. What is the ratio of the Balance of Payment (as % of commercial service exports) of Latin America(all income levels) in 2008 to that in 2011?
Your answer should be very brief. 1.1. What is the ratio of the Balance of Payment (as % of commercial service exports) in Middle income in 2008 to that in 2011?
Ensure brevity in your answer.  1.13. What is the ratio of the Balance of Payment (as % of commercial service exports) of Seychelles in 2008 to that in 2011?
Offer a very short reply. 1.04. What is the ratio of the Balance of Payment (as % of commercial service exports) in Latin America(all income levels) in 2008 to that in 2012?
Offer a very short reply. 1.16. What is the ratio of the Balance of Payment (as % of commercial service exports) in Middle income in 2008 to that in 2012?
Give a very brief answer. 1.19. What is the ratio of the Balance of Payment (as % of commercial service exports) of Seychelles in 2008 to that in 2012?
Provide a succinct answer. 1.4. What is the ratio of the Balance of Payment (as % of commercial service exports) in Latin America(all income levels) in 2009 to that in 2010?
Offer a terse response. 1.02. What is the ratio of the Balance of Payment (as % of commercial service exports) of Middle income in 2009 to that in 2010?
Your response must be concise. 0.95. What is the ratio of the Balance of Payment (as % of commercial service exports) of Seychelles in 2009 to that in 2010?
Offer a terse response. 1.08. What is the ratio of the Balance of Payment (as % of commercial service exports) of Latin America(all income levels) in 2009 to that in 2011?
Provide a succinct answer. 1.03. What is the ratio of the Balance of Payment (as % of commercial service exports) in Middle income in 2009 to that in 2011?
Keep it short and to the point. 0.96. What is the ratio of the Balance of Payment (as % of commercial service exports) in Seychelles in 2009 to that in 2011?
Provide a succinct answer. 1.1. What is the ratio of the Balance of Payment (as % of commercial service exports) of Latin America(all income levels) in 2009 to that in 2012?
Make the answer very short. 1.09. What is the ratio of the Balance of Payment (as % of commercial service exports) in Middle income in 2009 to that in 2012?
Keep it short and to the point. 1.01. What is the ratio of the Balance of Payment (as % of commercial service exports) of Seychelles in 2009 to that in 2012?
Ensure brevity in your answer.  1.49. What is the ratio of the Balance of Payment (as % of commercial service exports) of Latin America(all income levels) in 2010 to that in 2011?
Your answer should be compact. 1.01. What is the ratio of the Balance of Payment (as % of commercial service exports) of Middle income in 2010 to that in 2011?
Ensure brevity in your answer.  1.01. What is the ratio of the Balance of Payment (as % of commercial service exports) in Seychelles in 2010 to that in 2011?
Your response must be concise. 1.02. What is the ratio of the Balance of Payment (as % of commercial service exports) in Latin America(all income levels) in 2010 to that in 2012?
Offer a very short reply. 1.07. What is the ratio of the Balance of Payment (as % of commercial service exports) in Middle income in 2010 to that in 2012?
Make the answer very short. 1.07. What is the ratio of the Balance of Payment (as % of commercial service exports) of Seychelles in 2010 to that in 2012?
Offer a terse response. 1.38. What is the ratio of the Balance of Payment (as % of commercial service exports) in Latin America(all income levels) in 2011 to that in 2012?
Your response must be concise. 1.06. What is the ratio of the Balance of Payment (as % of commercial service exports) of Middle income in 2011 to that in 2012?
Your answer should be very brief. 1.05. What is the ratio of the Balance of Payment (as % of commercial service exports) in Seychelles in 2011 to that in 2012?
Keep it short and to the point. 1.35. What is the difference between the highest and the second highest Balance of Payment (as % of commercial service exports) in Latin America(all income levels)?
Give a very brief answer. 0.61. What is the difference between the highest and the second highest Balance of Payment (as % of commercial service exports) of Middle income?
Give a very brief answer. 1.02. What is the difference between the highest and the second highest Balance of Payment (as % of commercial service exports) of Seychelles?
Your answer should be compact. 0.83. What is the difference between the highest and the lowest Balance of Payment (as % of commercial service exports) in Latin America(all income levels)?
Provide a succinct answer. 3.54. What is the difference between the highest and the lowest Balance of Payment (as % of commercial service exports) of Middle income?
Offer a very short reply. 3.66. What is the difference between the highest and the lowest Balance of Payment (as % of commercial service exports) in Seychelles?
Your response must be concise. 17.68. 